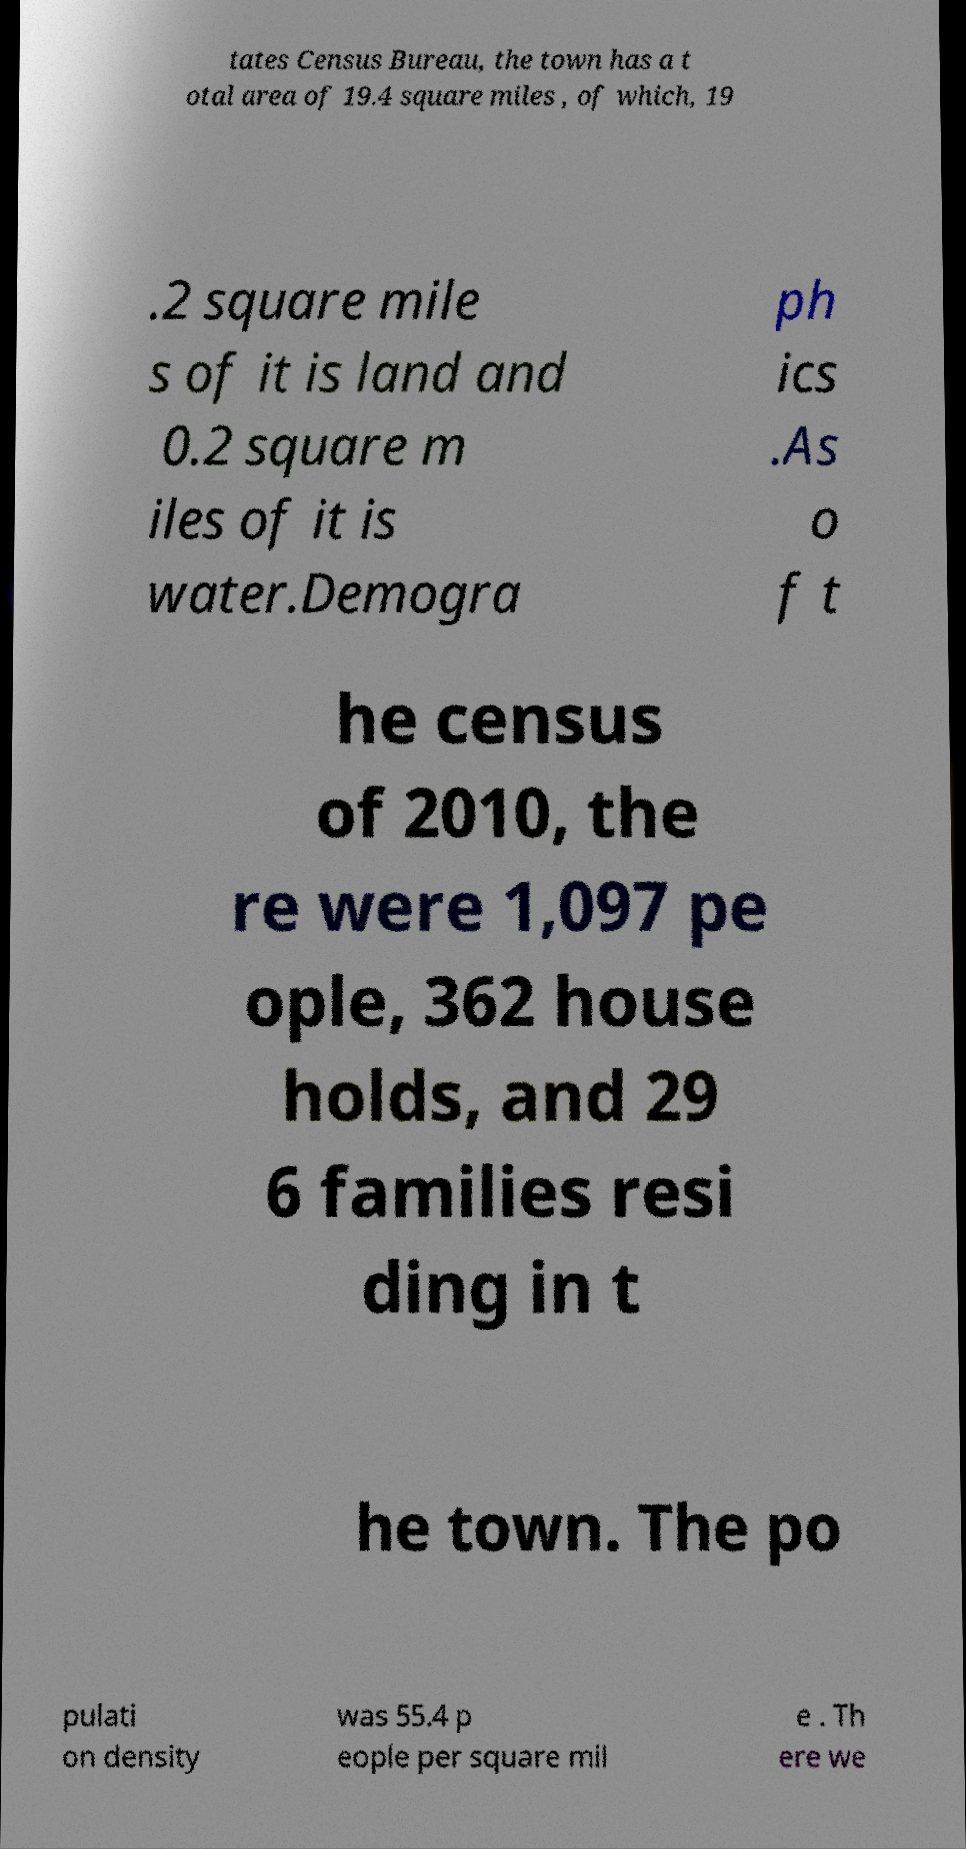Please read and relay the text visible in this image. What does it say? tates Census Bureau, the town has a t otal area of 19.4 square miles , of which, 19 .2 square mile s of it is land and 0.2 square m iles of it is water.Demogra ph ics .As o f t he census of 2010, the re were 1,097 pe ople, 362 house holds, and 29 6 families resi ding in t he town. The po pulati on density was 55.4 p eople per square mil e . Th ere we 